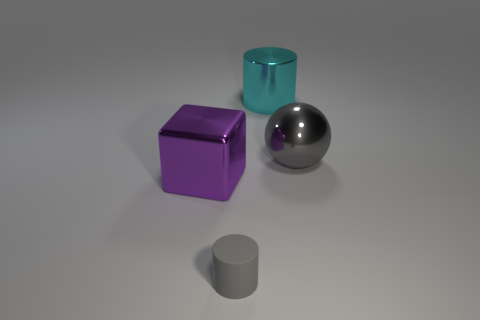Add 3 big green rubber blocks. How many objects exist? 7 Add 3 small gray cylinders. How many small gray cylinders exist? 4 Subtract 1 gray spheres. How many objects are left? 3 Subtract all cubes. How many objects are left? 3 Subtract all large cyan metallic things. Subtract all cylinders. How many objects are left? 1 Add 4 cyan metal cylinders. How many cyan metal cylinders are left? 5 